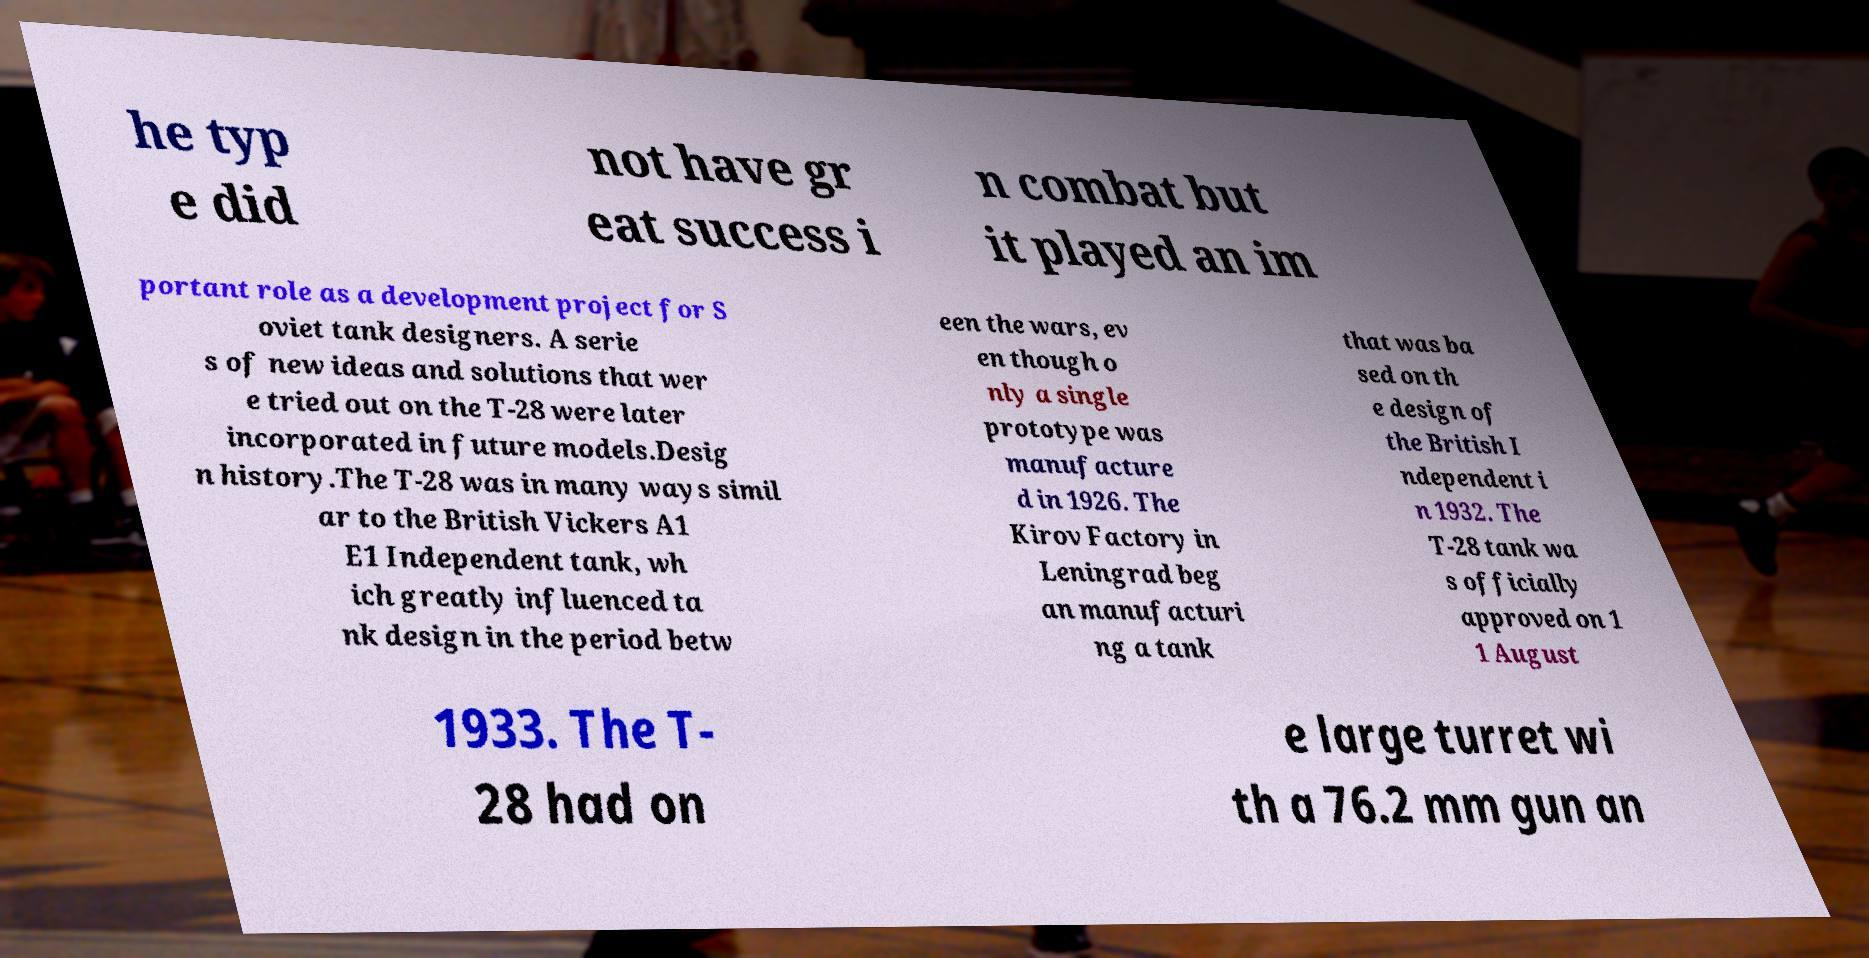Please identify and transcribe the text found in this image. he typ e did not have gr eat success i n combat but it played an im portant role as a development project for S oviet tank designers. A serie s of new ideas and solutions that wer e tried out on the T-28 were later incorporated in future models.Desig n history.The T-28 was in many ways simil ar to the British Vickers A1 E1 Independent tank, wh ich greatly influenced ta nk design in the period betw een the wars, ev en though o nly a single prototype was manufacture d in 1926. The Kirov Factory in Leningrad beg an manufacturi ng a tank that was ba sed on th e design of the British I ndependent i n 1932. The T-28 tank wa s officially approved on 1 1 August 1933. The T- 28 had on e large turret wi th a 76.2 mm gun an 